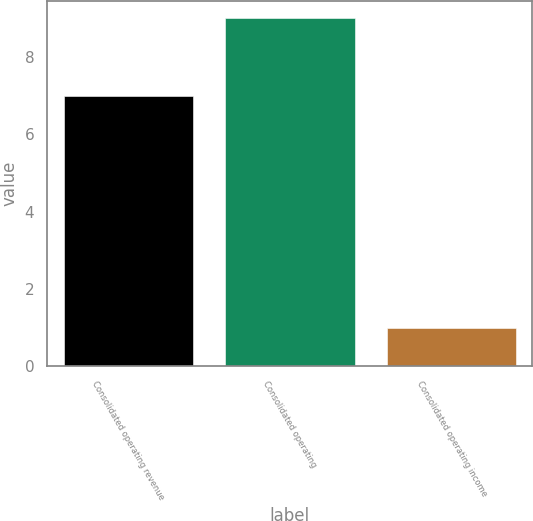<chart> <loc_0><loc_0><loc_500><loc_500><bar_chart><fcel>Consolidated operating revenue<fcel>Consolidated operating<fcel>Consolidated operating income<nl><fcel>7<fcel>9<fcel>1<nl></chart> 